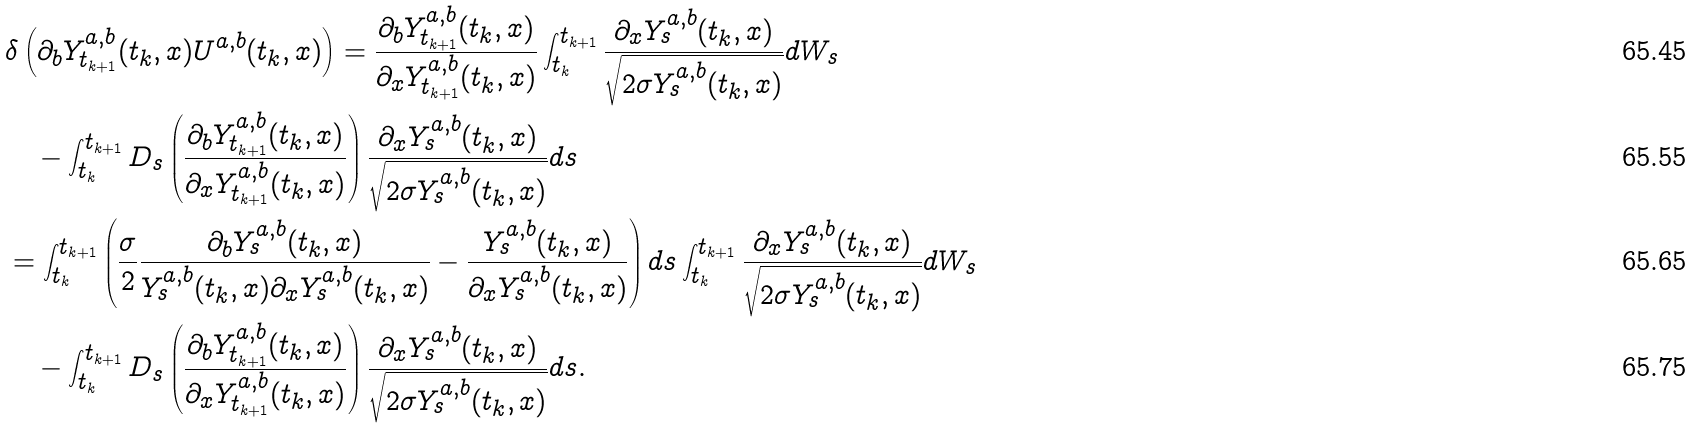Convert formula to latex. <formula><loc_0><loc_0><loc_500><loc_500>& \delta \left ( \partial _ { b } Y _ { t _ { k + 1 } } ^ { a , b } ( t _ { k } , x ) U ^ { a , b } ( t _ { k } , x ) \right ) = \frac { \partial _ { b } Y _ { t _ { k + 1 } } ^ { a , b } ( t _ { k } , x ) } { \partial _ { x } Y _ { t _ { k + 1 } } ^ { a , b } ( t _ { k } , x ) } \int _ { t _ { k } } ^ { t _ { k + 1 } } \frac { \partial _ { x } Y _ { s } ^ { a , b } ( t _ { k } , x ) } { \sqrt { 2 \sigma Y _ { s } ^ { a , b } ( t _ { k } , x ) } } d W _ { s } \\ & \quad - \int _ { t _ { k } } ^ { t _ { k + 1 } } D _ { s } \left ( \frac { \partial _ { b } Y _ { t _ { k + 1 } } ^ { a , b } ( t _ { k } , x ) } { \partial _ { x } Y _ { t _ { k + 1 } } ^ { a , b } ( t _ { k } , x ) } \right ) \frac { \partial _ { x } Y _ { s } ^ { a , b } ( t _ { k } , x ) } { \sqrt { 2 \sigma Y _ { s } ^ { a , b } ( t _ { k } , x ) } } d s \\ & = \int _ { t _ { k } } ^ { t _ { k + 1 } } \left ( \frac { \sigma } { 2 } \frac { \partial _ { b } Y _ { s } ^ { a , b } ( t _ { k } , x ) } { Y _ { s } ^ { a , b } ( t _ { k } , x ) \partial _ { x } Y _ { s } ^ { a , b } ( t _ { k } , x ) } - \frac { Y _ { s } ^ { a , b } ( t _ { k } , x ) } { \partial _ { x } Y _ { s } ^ { a , b } ( t _ { k } , x ) } \right ) d s \int _ { t _ { k } } ^ { t _ { k + 1 } } \frac { \partial _ { x } Y _ { s } ^ { a , b } ( t _ { k } , x ) } { \sqrt { 2 \sigma Y _ { s } ^ { a , b } ( t _ { k } , x ) } } d W _ { s } \\ & \quad - \int _ { t _ { k } } ^ { t _ { k + 1 } } D _ { s } \left ( \frac { \partial _ { b } Y _ { t _ { k + 1 } } ^ { a , b } ( t _ { k } , x ) } { \partial _ { x } Y _ { t _ { k + 1 } } ^ { a , b } ( t _ { k } , x ) } \right ) \frac { \partial _ { x } Y _ { s } ^ { a , b } ( t _ { k } , x ) } { \sqrt { 2 \sigma Y _ { s } ^ { a , b } ( t _ { k } , x ) } } d s .</formula> 